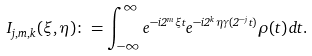<formula> <loc_0><loc_0><loc_500><loc_500>I _ { j , m , k } ( \xi , \eta ) \colon = \int _ { - \infty } ^ { \infty } e ^ { - i 2 ^ { m } \xi t } e ^ { - i 2 ^ { k } \eta \gamma ( 2 ^ { - j } t ) } \rho ( t ) \, d t .</formula> 